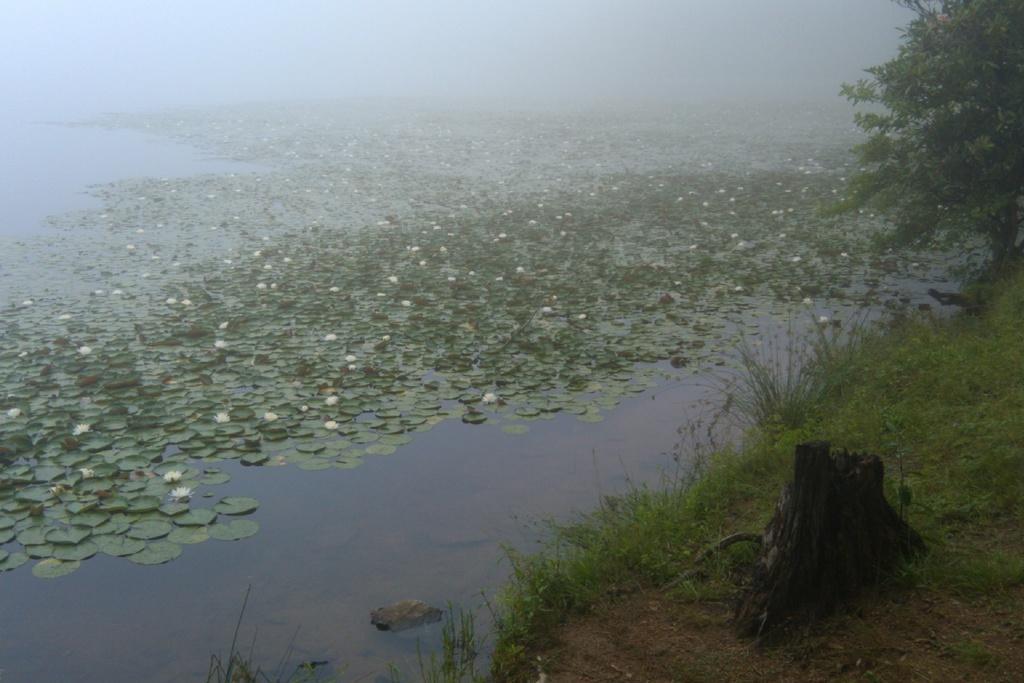Please provide a concise description of this image. In this image I can see lotus flowers and leaves all over the pond and in the right bottom corner I can see trees and grass. 